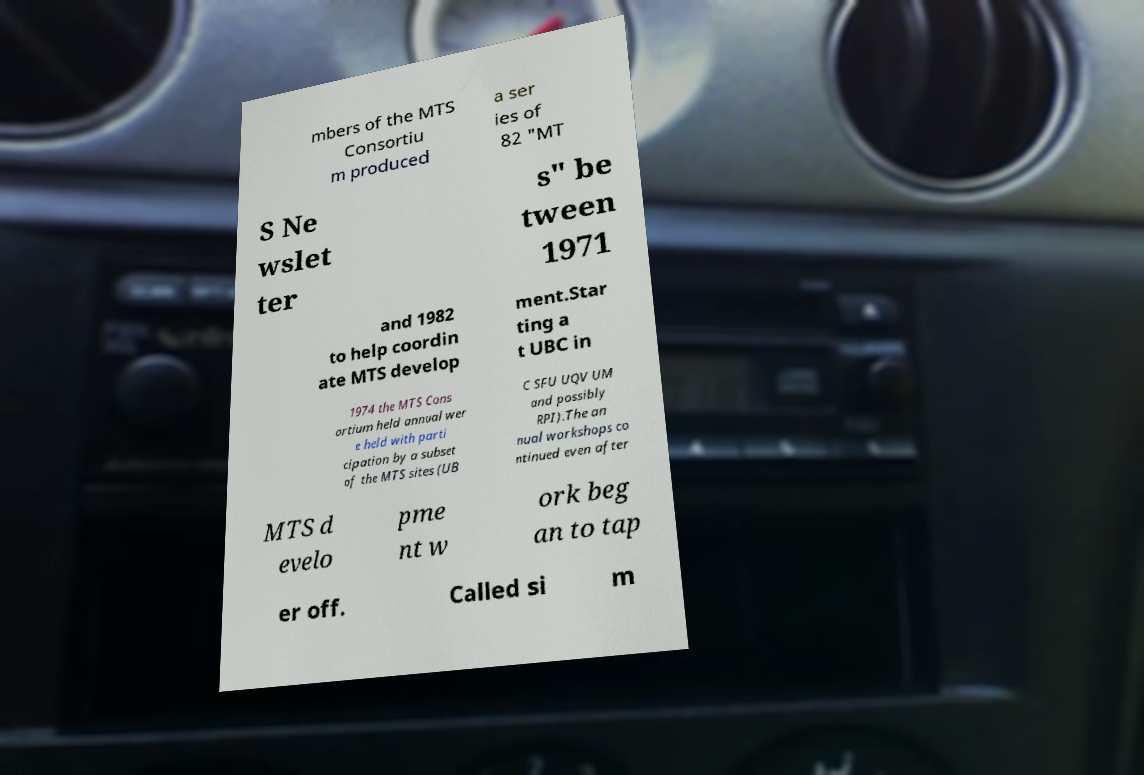Please identify and transcribe the text found in this image. mbers of the MTS Consortiu m produced a ser ies of 82 "MT S Ne wslet ter s" be tween 1971 and 1982 to help coordin ate MTS develop ment.Star ting a t UBC in 1974 the MTS Cons ortium held annual wer e held with parti cipation by a subset of the MTS sites (UB C SFU UQV UM and possibly RPI).The an nual workshops co ntinued even after MTS d evelo pme nt w ork beg an to tap er off. Called si m 